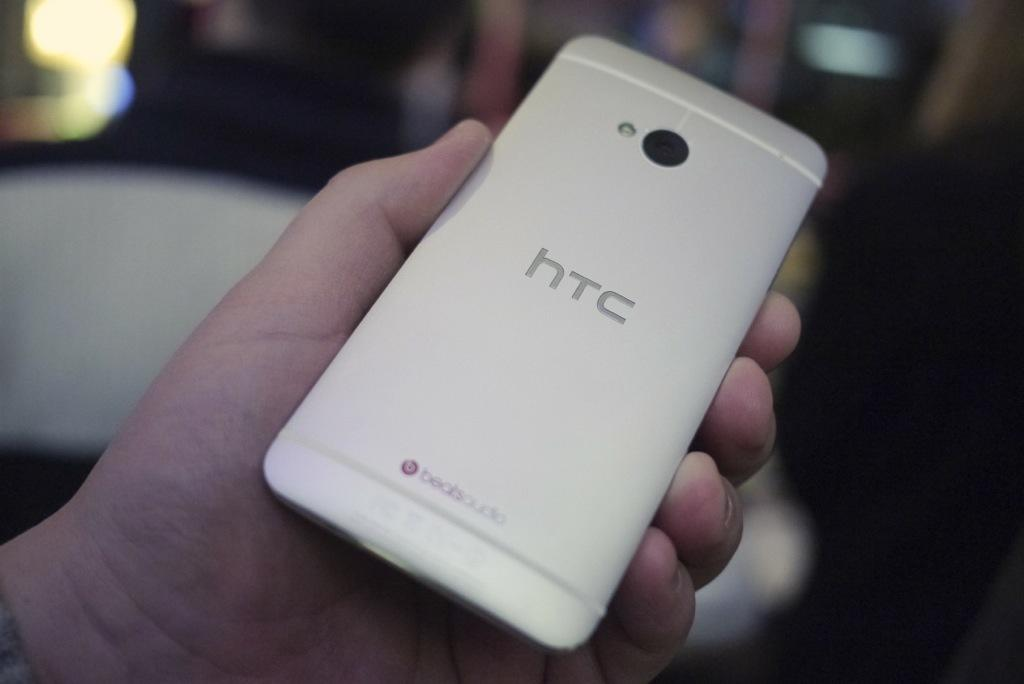<image>
Relay a brief, clear account of the picture shown. Htc phone being held up by a random hand 